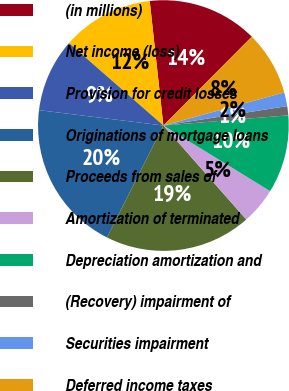<chart> <loc_0><loc_0><loc_500><loc_500><pie_chart><fcel>(in millions)<fcel>Net income (loss)<fcel>Provision for credit losses<fcel>Originations of mortgage loans<fcel>Proceeds from sales of<fcel>Amortization of terminated<fcel>Depreciation amortization and<fcel>(Recovery) impairment of<fcel>Securities impairment<fcel>Deferred income taxes<nl><fcel>14.2%<fcel>11.83%<fcel>9.47%<fcel>19.53%<fcel>18.93%<fcel>4.73%<fcel>10.06%<fcel>1.18%<fcel>1.78%<fcel>8.28%<nl></chart> 